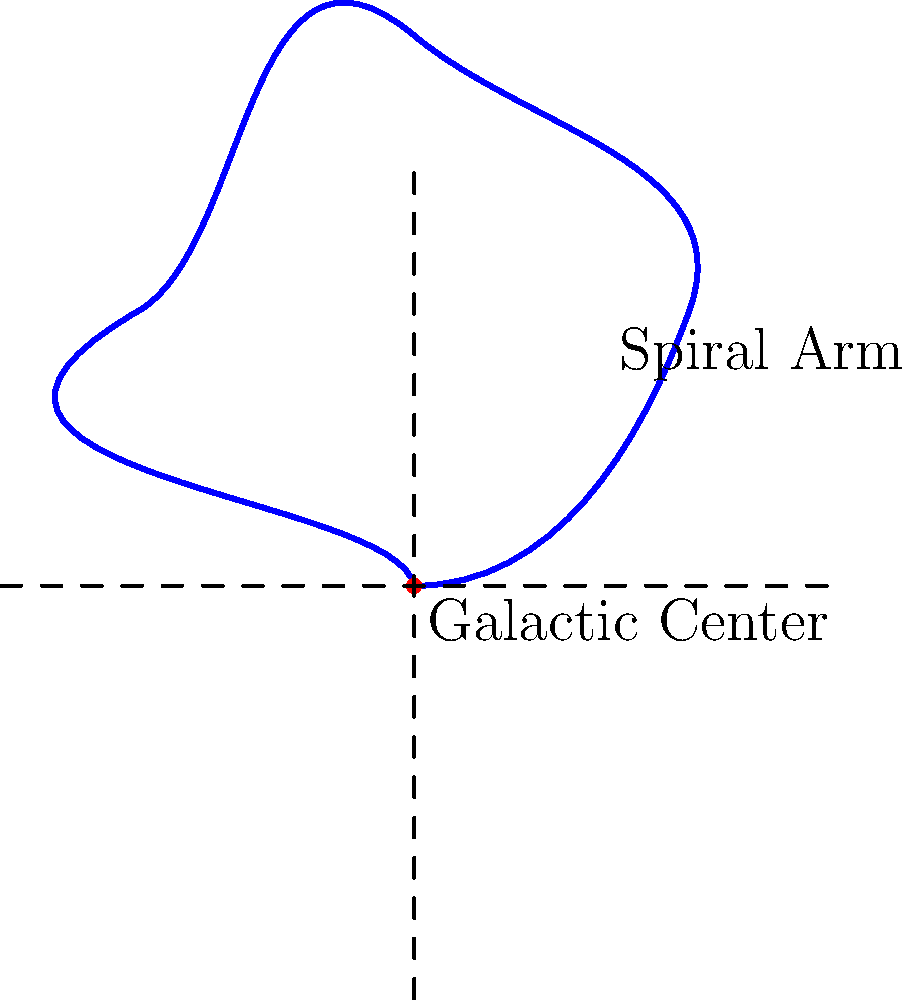As a strategist advising the CEO on market impact, you're analyzing a simplified model of galaxy structure. In the diagram, what fundamental component of a spiral galaxy is represented by the red dot at the center, and how might understanding this structure influence potential market strategies for space-based technologies or services? To answer this question, let's break down the key elements of the diagram and their significance:

1. The blue spiral represents the overall structure of a spiral galaxy.
2. The red dot at the center is a crucial feature of the galaxy's structure.

Step-by-step analysis:
1. The red dot at the center represents the galactic center or galactic core.
2. In real spiral galaxies, this core often contains a supermassive black hole and a high concentration of stars.
3. Understanding the galactic center is vital for several reasons:
   a) It's a region of intense gravitational forces and high-energy phenomena.
   b) It often emits strong radio waves and X-rays, which can be detected by space-based observatories.
   c) The core influences the overall structure and dynamics of the galaxy.

4. From a market strategy perspective, understanding this structure could influence:
   a) Development of specialized instruments for observing galactic cores.
   b) Design of communication systems that can operate in high-radiation environments.
   c) Planning of future deep-space missions or space-based observatories.
   d) Creation of data analysis tools for processing complex astronomical data.
   e) Potential for space tourism offerings focused on observing galactic phenomena.

5. The CEO could use this information to:
   a) Identify new market opportunities in space technology and services.
   b) Allocate resources for R&D in relevant areas.
   c) Develop partnerships with astronomical research institutions.
   d) Position the company as a leader in space-based technologies or services related to galactic observation and exploration.

Understanding the fundamental structure of galaxies, particularly the significance of the galactic center, can inform strategic decisions about product development, market positioning, and long-term investment in space-related technologies and services.
Answer: Galactic center; informs space tech market strategies. 